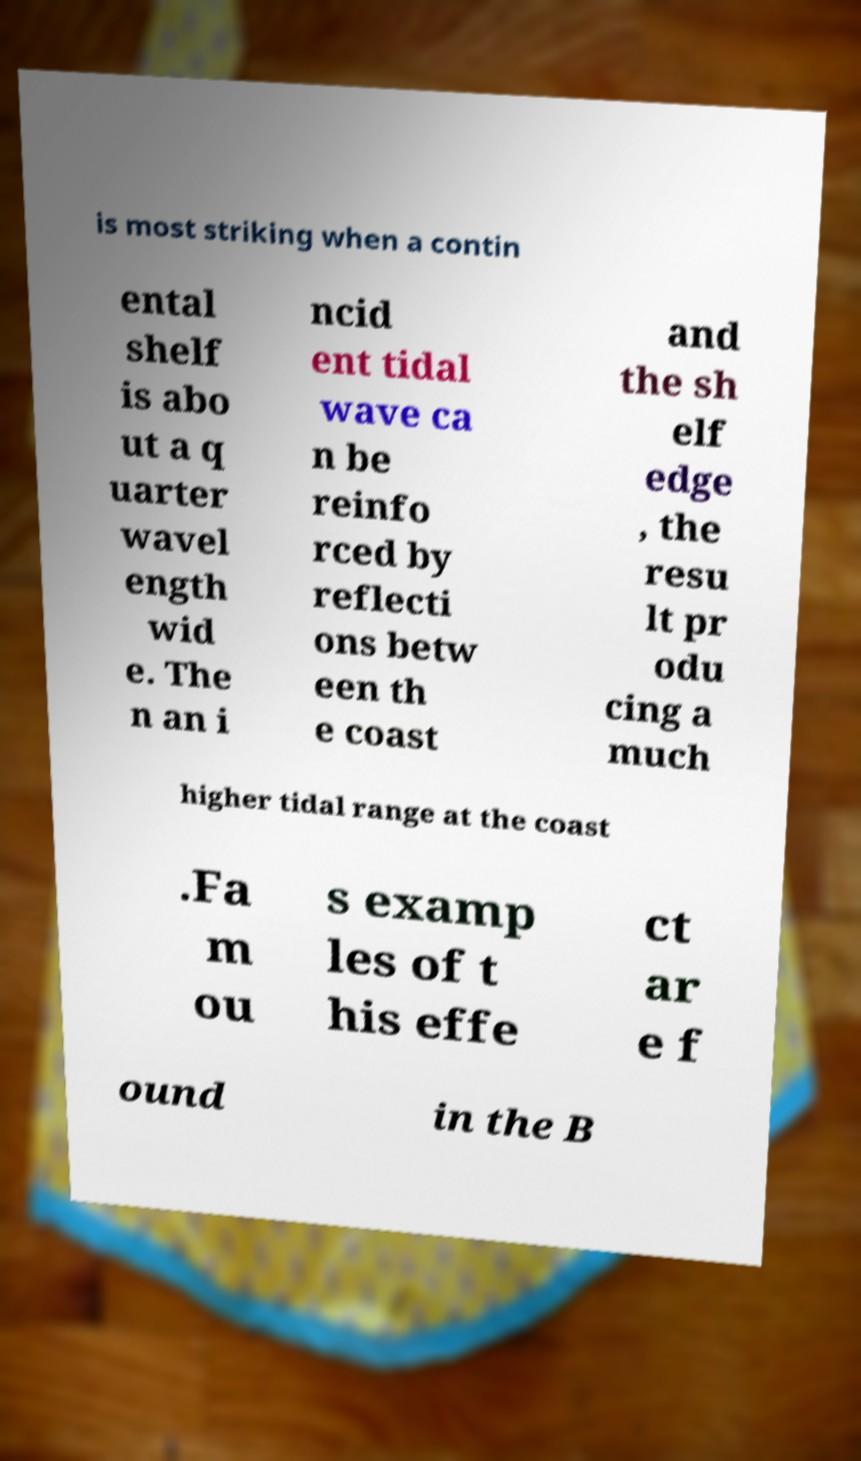I need the written content from this picture converted into text. Can you do that? is most striking when a contin ental shelf is abo ut a q uarter wavel ength wid e. The n an i ncid ent tidal wave ca n be reinfo rced by reflecti ons betw een th e coast and the sh elf edge , the resu lt pr odu cing a much higher tidal range at the coast .Fa m ou s examp les of t his effe ct ar e f ound in the B 